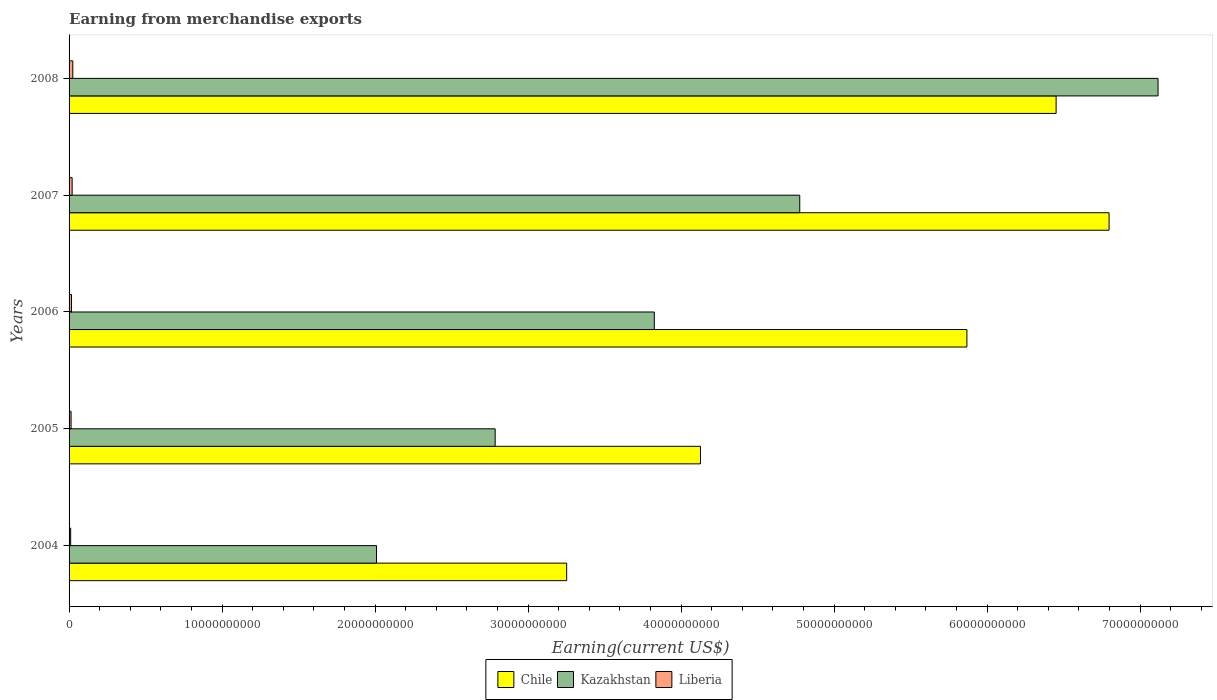How many different coloured bars are there?
Offer a very short reply. 3. How many groups of bars are there?
Your answer should be compact. 5. Are the number of bars per tick equal to the number of legend labels?
Your answer should be compact. Yes. How many bars are there on the 3rd tick from the bottom?
Ensure brevity in your answer.  3. What is the amount earned from merchandise exports in Liberia in 2008?
Provide a succinct answer. 2.42e+08. Across all years, what is the maximum amount earned from merchandise exports in Liberia?
Give a very brief answer. 2.42e+08. Across all years, what is the minimum amount earned from merchandise exports in Liberia?
Your answer should be compact. 1.04e+08. In which year was the amount earned from merchandise exports in Chile maximum?
Give a very brief answer. 2007. What is the total amount earned from merchandise exports in Chile in the graph?
Give a very brief answer. 2.65e+11. What is the difference between the amount earned from merchandise exports in Liberia in 2006 and that in 2008?
Make the answer very short. -8.46e+07. What is the difference between the amount earned from merchandise exports in Kazakhstan in 2006 and the amount earned from merchandise exports in Chile in 2008?
Offer a terse response. -2.63e+1. What is the average amount earned from merchandise exports in Chile per year?
Your answer should be compact. 5.30e+1. In the year 2004, what is the difference between the amount earned from merchandise exports in Liberia and amount earned from merchandise exports in Kazakhstan?
Provide a succinct answer. -2.00e+1. In how many years, is the amount earned from merchandise exports in Chile greater than 44000000000 US$?
Provide a succinct answer. 3. What is the ratio of the amount earned from merchandise exports in Kazakhstan in 2004 to that in 2008?
Ensure brevity in your answer.  0.28. Is the amount earned from merchandise exports in Kazakhstan in 2006 less than that in 2008?
Offer a very short reply. Yes. What is the difference between the highest and the second highest amount earned from merchandise exports in Chile?
Your answer should be very brief. 3.46e+09. What is the difference between the highest and the lowest amount earned from merchandise exports in Liberia?
Offer a very short reply. 1.39e+08. In how many years, is the amount earned from merchandise exports in Chile greater than the average amount earned from merchandise exports in Chile taken over all years?
Offer a terse response. 3. Is the sum of the amount earned from merchandise exports in Chile in 2004 and 2005 greater than the maximum amount earned from merchandise exports in Kazakhstan across all years?
Provide a succinct answer. Yes. What does the 3rd bar from the top in 2004 represents?
Give a very brief answer. Chile. What does the 3rd bar from the bottom in 2008 represents?
Provide a short and direct response. Liberia. Is it the case that in every year, the sum of the amount earned from merchandise exports in Chile and amount earned from merchandise exports in Kazakhstan is greater than the amount earned from merchandise exports in Liberia?
Offer a terse response. Yes. How many years are there in the graph?
Offer a very short reply. 5. Are the values on the major ticks of X-axis written in scientific E-notation?
Your answer should be very brief. No. Does the graph contain grids?
Make the answer very short. No. How many legend labels are there?
Offer a very short reply. 3. How are the legend labels stacked?
Your answer should be very brief. Horizontal. What is the title of the graph?
Your answer should be compact. Earning from merchandise exports. Does "Timor-Leste" appear as one of the legend labels in the graph?
Give a very brief answer. No. What is the label or title of the X-axis?
Provide a short and direct response. Earning(current US$). What is the Earning(current US$) in Chile in 2004?
Provide a short and direct response. 3.25e+1. What is the Earning(current US$) in Kazakhstan in 2004?
Your response must be concise. 2.01e+1. What is the Earning(current US$) of Liberia in 2004?
Ensure brevity in your answer.  1.04e+08. What is the Earning(current US$) in Chile in 2005?
Ensure brevity in your answer.  4.13e+1. What is the Earning(current US$) of Kazakhstan in 2005?
Offer a very short reply. 2.78e+1. What is the Earning(current US$) in Liberia in 2005?
Keep it short and to the point. 1.31e+08. What is the Earning(current US$) in Chile in 2006?
Offer a terse response. 5.87e+1. What is the Earning(current US$) in Kazakhstan in 2006?
Ensure brevity in your answer.  3.82e+1. What is the Earning(current US$) in Liberia in 2006?
Your response must be concise. 1.58e+08. What is the Earning(current US$) of Chile in 2007?
Give a very brief answer. 6.80e+1. What is the Earning(current US$) in Kazakhstan in 2007?
Your response must be concise. 4.78e+1. What is the Earning(current US$) in Liberia in 2007?
Provide a short and direct response. 2.00e+08. What is the Earning(current US$) in Chile in 2008?
Provide a short and direct response. 6.45e+1. What is the Earning(current US$) in Kazakhstan in 2008?
Offer a very short reply. 7.12e+1. What is the Earning(current US$) in Liberia in 2008?
Ensure brevity in your answer.  2.42e+08. Across all years, what is the maximum Earning(current US$) of Chile?
Provide a succinct answer. 6.80e+1. Across all years, what is the maximum Earning(current US$) of Kazakhstan?
Provide a short and direct response. 7.12e+1. Across all years, what is the maximum Earning(current US$) of Liberia?
Your answer should be very brief. 2.42e+08. Across all years, what is the minimum Earning(current US$) of Chile?
Your answer should be very brief. 3.25e+1. Across all years, what is the minimum Earning(current US$) in Kazakhstan?
Provide a short and direct response. 2.01e+1. Across all years, what is the minimum Earning(current US$) of Liberia?
Give a very brief answer. 1.04e+08. What is the total Earning(current US$) of Chile in the graph?
Provide a short and direct response. 2.65e+11. What is the total Earning(current US$) of Kazakhstan in the graph?
Provide a short and direct response. 2.05e+11. What is the total Earning(current US$) of Liberia in the graph?
Make the answer very short. 8.36e+08. What is the difference between the Earning(current US$) of Chile in 2004 and that in 2005?
Your answer should be very brief. -8.75e+09. What is the difference between the Earning(current US$) of Kazakhstan in 2004 and that in 2005?
Provide a short and direct response. -7.76e+09. What is the difference between the Earning(current US$) of Liberia in 2004 and that in 2005?
Your response must be concise. -2.75e+07. What is the difference between the Earning(current US$) in Chile in 2004 and that in 2006?
Your answer should be very brief. -2.62e+1. What is the difference between the Earning(current US$) in Kazakhstan in 2004 and that in 2006?
Offer a terse response. -1.82e+1. What is the difference between the Earning(current US$) in Liberia in 2004 and that in 2006?
Keep it short and to the point. -5.40e+07. What is the difference between the Earning(current US$) in Chile in 2004 and that in 2007?
Your answer should be compact. -3.55e+1. What is the difference between the Earning(current US$) of Kazakhstan in 2004 and that in 2007?
Provide a short and direct response. -2.77e+1. What is the difference between the Earning(current US$) of Liberia in 2004 and that in 2007?
Keep it short and to the point. -9.64e+07. What is the difference between the Earning(current US$) in Chile in 2004 and that in 2008?
Make the answer very short. -3.20e+1. What is the difference between the Earning(current US$) of Kazakhstan in 2004 and that in 2008?
Your answer should be compact. -5.11e+1. What is the difference between the Earning(current US$) of Liberia in 2004 and that in 2008?
Keep it short and to the point. -1.39e+08. What is the difference between the Earning(current US$) in Chile in 2005 and that in 2006?
Provide a short and direct response. -1.74e+1. What is the difference between the Earning(current US$) in Kazakhstan in 2005 and that in 2006?
Offer a terse response. -1.04e+1. What is the difference between the Earning(current US$) of Liberia in 2005 and that in 2006?
Your answer should be very brief. -2.65e+07. What is the difference between the Earning(current US$) of Chile in 2005 and that in 2007?
Provide a succinct answer. -2.67e+1. What is the difference between the Earning(current US$) of Kazakhstan in 2005 and that in 2007?
Your response must be concise. -1.99e+1. What is the difference between the Earning(current US$) of Liberia in 2005 and that in 2007?
Ensure brevity in your answer.  -6.89e+07. What is the difference between the Earning(current US$) of Chile in 2005 and that in 2008?
Offer a very short reply. -2.32e+1. What is the difference between the Earning(current US$) of Kazakhstan in 2005 and that in 2008?
Give a very brief answer. -4.33e+1. What is the difference between the Earning(current US$) in Liberia in 2005 and that in 2008?
Provide a short and direct response. -1.11e+08. What is the difference between the Earning(current US$) in Chile in 2006 and that in 2007?
Give a very brief answer. -9.29e+09. What is the difference between the Earning(current US$) in Kazakhstan in 2006 and that in 2007?
Your response must be concise. -9.50e+09. What is the difference between the Earning(current US$) in Liberia in 2006 and that in 2007?
Keep it short and to the point. -4.24e+07. What is the difference between the Earning(current US$) of Chile in 2006 and that in 2008?
Offer a terse response. -5.83e+09. What is the difference between the Earning(current US$) in Kazakhstan in 2006 and that in 2008?
Give a very brief answer. -3.29e+1. What is the difference between the Earning(current US$) in Liberia in 2006 and that in 2008?
Your answer should be very brief. -8.46e+07. What is the difference between the Earning(current US$) in Chile in 2007 and that in 2008?
Give a very brief answer. 3.46e+09. What is the difference between the Earning(current US$) of Kazakhstan in 2007 and that in 2008?
Your response must be concise. -2.34e+1. What is the difference between the Earning(current US$) of Liberia in 2007 and that in 2008?
Ensure brevity in your answer.  -4.22e+07. What is the difference between the Earning(current US$) of Chile in 2004 and the Earning(current US$) of Kazakhstan in 2005?
Offer a terse response. 4.67e+09. What is the difference between the Earning(current US$) in Chile in 2004 and the Earning(current US$) in Liberia in 2005?
Provide a succinct answer. 3.24e+1. What is the difference between the Earning(current US$) of Kazakhstan in 2004 and the Earning(current US$) of Liberia in 2005?
Give a very brief answer. 2.00e+1. What is the difference between the Earning(current US$) in Chile in 2004 and the Earning(current US$) in Kazakhstan in 2006?
Make the answer very short. -5.73e+09. What is the difference between the Earning(current US$) of Chile in 2004 and the Earning(current US$) of Liberia in 2006?
Keep it short and to the point. 3.24e+1. What is the difference between the Earning(current US$) in Kazakhstan in 2004 and the Earning(current US$) in Liberia in 2006?
Give a very brief answer. 1.99e+1. What is the difference between the Earning(current US$) in Chile in 2004 and the Earning(current US$) in Kazakhstan in 2007?
Ensure brevity in your answer.  -1.52e+1. What is the difference between the Earning(current US$) of Chile in 2004 and the Earning(current US$) of Liberia in 2007?
Your answer should be very brief. 3.23e+1. What is the difference between the Earning(current US$) in Kazakhstan in 2004 and the Earning(current US$) in Liberia in 2007?
Your answer should be very brief. 1.99e+1. What is the difference between the Earning(current US$) of Chile in 2004 and the Earning(current US$) of Kazakhstan in 2008?
Provide a short and direct response. -3.87e+1. What is the difference between the Earning(current US$) of Chile in 2004 and the Earning(current US$) of Liberia in 2008?
Your answer should be compact. 3.23e+1. What is the difference between the Earning(current US$) in Kazakhstan in 2004 and the Earning(current US$) in Liberia in 2008?
Your answer should be very brief. 1.99e+1. What is the difference between the Earning(current US$) in Chile in 2005 and the Earning(current US$) in Kazakhstan in 2006?
Offer a very short reply. 3.02e+09. What is the difference between the Earning(current US$) in Chile in 2005 and the Earning(current US$) in Liberia in 2006?
Make the answer very short. 4.11e+1. What is the difference between the Earning(current US$) of Kazakhstan in 2005 and the Earning(current US$) of Liberia in 2006?
Make the answer very short. 2.77e+1. What is the difference between the Earning(current US$) in Chile in 2005 and the Earning(current US$) in Kazakhstan in 2007?
Your answer should be compact. -6.49e+09. What is the difference between the Earning(current US$) of Chile in 2005 and the Earning(current US$) of Liberia in 2007?
Provide a succinct answer. 4.11e+1. What is the difference between the Earning(current US$) of Kazakhstan in 2005 and the Earning(current US$) of Liberia in 2007?
Offer a terse response. 2.76e+1. What is the difference between the Earning(current US$) in Chile in 2005 and the Earning(current US$) in Kazakhstan in 2008?
Your response must be concise. -2.99e+1. What is the difference between the Earning(current US$) in Chile in 2005 and the Earning(current US$) in Liberia in 2008?
Give a very brief answer. 4.10e+1. What is the difference between the Earning(current US$) of Kazakhstan in 2005 and the Earning(current US$) of Liberia in 2008?
Your answer should be compact. 2.76e+1. What is the difference between the Earning(current US$) in Chile in 2006 and the Earning(current US$) in Kazakhstan in 2007?
Offer a very short reply. 1.09e+1. What is the difference between the Earning(current US$) of Chile in 2006 and the Earning(current US$) of Liberia in 2007?
Offer a very short reply. 5.85e+1. What is the difference between the Earning(current US$) in Kazakhstan in 2006 and the Earning(current US$) in Liberia in 2007?
Your answer should be very brief. 3.80e+1. What is the difference between the Earning(current US$) in Chile in 2006 and the Earning(current US$) in Kazakhstan in 2008?
Your answer should be very brief. -1.25e+1. What is the difference between the Earning(current US$) of Chile in 2006 and the Earning(current US$) of Liberia in 2008?
Your response must be concise. 5.84e+1. What is the difference between the Earning(current US$) in Kazakhstan in 2006 and the Earning(current US$) in Liberia in 2008?
Give a very brief answer. 3.80e+1. What is the difference between the Earning(current US$) of Chile in 2007 and the Earning(current US$) of Kazakhstan in 2008?
Offer a terse response. -3.20e+09. What is the difference between the Earning(current US$) in Chile in 2007 and the Earning(current US$) in Liberia in 2008?
Provide a succinct answer. 6.77e+1. What is the difference between the Earning(current US$) of Kazakhstan in 2007 and the Earning(current US$) of Liberia in 2008?
Your answer should be very brief. 4.75e+1. What is the average Earning(current US$) in Chile per year?
Your response must be concise. 5.30e+1. What is the average Earning(current US$) of Kazakhstan per year?
Your response must be concise. 4.10e+1. What is the average Earning(current US$) of Liberia per year?
Provide a succinct answer. 1.67e+08. In the year 2004, what is the difference between the Earning(current US$) of Chile and Earning(current US$) of Kazakhstan?
Make the answer very short. 1.24e+1. In the year 2004, what is the difference between the Earning(current US$) in Chile and Earning(current US$) in Liberia?
Your answer should be very brief. 3.24e+1. In the year 2004, what is the difference between the Earning(current US$) in Kazakhstan and Earning(current US$) in Liberia?
Make the answer very short. 2.00e+1. In the year 2005, what is the difference between the Earning(current US$) of Chile and Earning(current US$) of Kazakhstan?
Offer a very short reply. 1.34e+1. In the year 2005, what is the difference between the Earning(current US$) in Chile and Earning(current US$) in Liberia?
Offer a very short reply. 4.11e+1. In the year 2005, what is the difference between the Earning(current US$) in Kazakhstan and Earning(current US$) in Liberia?
Make the answer very short. 2.77e+1. In the year 2006, what is the difference between the Earning(current US$) of Chile and Earning(current US$) of Kazakhstan?
Provide a succinct answer. 2.04e+1. In the year 2006, what is the difference between the Earning(current US$) in Chile and Earning(current US$) in Liberia?
Your response must be concise. 5.85e+1. In the year 2006, what is the difference between the Earning(current US$) of Kazakhstan and Earning(current US$) of Liberia?
Offer a terse response. 3.81e+1. In the year 2007, what is the difference between the Earning(current US$) of Chile and Earning(current US$) of Kazakhstan?
Your response must be concise. 2.02e+1. In the year 2007, what is the difference between the Earning(current US$) in Chile and Earning(current US$) in Liberia?
Your answer should be very brief. 6.78e+1. In the year 2007, what is the difference between the Earning(current US$) of Kazakhstan and Earning(current US$) of Liberia?
Keep it short and to the point. 4.76e+1. In the year 2008, what is the difference between the Earning(current US$) in Chile and Earning(current US$) in Kazakhstan?
Offer a terse response. -6.66e+09. In the year 2008, what is the difference between the Earning(current US$) of Chile and Earning(current US$) of Liberia?
Keep it short and to the point. 6.43e+1. In the year 2008, what is the difference between the Earning(current US$) of Kazakhstan and Earning(current US$) of Liberia?
Provide a short and direct response. 7.09e+1. What is the ratio of the Earning(current US$) in Chile in 2004 to that in 2005?
Offer a terse response. 0.79. What is the ratio of the Earning(current US$) of Kazakhstan in 2004 to that in 2005?
Give a very brief answer. 0.72. What is the ratio of the Earning(current US$) of Liberia in 2004 to that in 2005?
Offer a terse response. 0.79. What is the ratio of the Earning(current US$) of Chile in 2004 to that in 2006?
Provide a short and direct response. 0.55. What is the ratio of the Earning(current US$) of Kazakhstan in 2004 to that in 2006?
Ensure brevity in your answer.  0.53. What is the ratio of the Earning(current US$) in Liberia in 2004 to that in 2006?
Make the answer very short. 0.66. What is the ratio of the Earning(current US$) in Chile in 2004 to that in 2007?
Your answer should be very brief. 0.48. What is the ratio of the Earning(current US$) in Kazakhstan in 2004 to that in 2007?
Provide a short and direct response. 0.42. What is the ratio of the Earning(current US$) of Liberia in 2004 to that in 2007?
Your answer should be compact. 0.52. What is the ratio of the Earning(current US$) in Chile in 2004 to that in 2008?
Offer a very short reply. 0.5. What is the ratio of the Earning(current US$) of Kazakhstan in 2004 to that in 2008?
Give a very brief answer. 0.28. What is the ratio of the Earning(current US$) in Liberia in 2004 to that in 2008?
Your answer should be very brief. 0.43. What is the ratio of the Earning(current US$) of Chile in 2005 to that in 2006?
Give a very brief answer. 0.7. What is the ratio of the Earning(current US$) of Kazakhstan in 2005 to that in 2006?
Offer a terse response. 0.73. What is the ratio of the Earning(current US$) of Liberia in 2005 to that in 2006?
Your answer should be very brief. 0.83. What is the ratio of the Earning(current US$) in Chile in 2005 to that in 2007?
Offer a terse response. 0.61. What is the ratio of the Earning(current US$) in Kazakhstan in 2005 to that in 2007?
Provide a succinct answer. 0.58. What is the ratio of the Earning(current US$) of Liberia in 2005 to that in 2007?
Your response must be concise. 0.66. What is the ratio of the Earning(current US$) in Chile in 2005 to that in 2008?
Your answer should be compact. 0.64. What is the ratio of the Earning(current US$) of Kazakhstan in 2005 to that in 2008?
Give a very brief answer. 0.39. What is the ratio of the Earning(current US$) in Liberia in 2005 to that in 2008?
Your response must be concise. 0.54. What is the ratio of the Earning(current US$) in Chile in 2006 to that in 2007?
Offer a terse response. 0.86. What is the ratio of the Earning(current US$) in Kazakhstan in 2006 to that in 2007?
Your response must be concise. 0.8. What is the ratio of the Earning(current US$) of Liberia in 2006 to that in 2007?
Ensure brevity in your answer.  0.79. What is the ratio of the Earning(current US$) of Chile in 2006 to that in 2008?
Your response must be concise. 0.91. What is the ratio of the Earning(current US$) in Kazakhstan in 2006 to that in 2008?
Ensure brevity in your answer.  0.54. What is the ratio of the Earning(current US$) in Liberia in 2006 to that in 2008?
Make the answer very short. 0.65. What is the ratio of the Earning(current US$) in Chile in 2007 to that in 2008?
Give a very brief answer. 1.05. What is the ratio of the Earning(current US$) of Kazakhstan in 2007 to that in 2008?
Provide a short and direct response. 0.67. What is the ratio of the Earning(current US$) of Liberia in 2007 to that in 2008?
Provide a succinct answer. 0.83. What is the difference between the highest and the second highest Earning(current US$) of Chile?
Provide a succinct answer. 3.46e+09. What is the difference between the highest and the second highest Earning(current US$) of Kazakhstan?
Give a very brief answer. 2.34e+1. What is the difference between the highest and the second highest Earning(current US$) in Liberia?
Offer a terse response. 4.22e+07. What is the difference between the highest and the lowest Earning(current US$) in Chile?
Offer a terse response. 3.55e+1. What is the difference between the highest and the lowest Earning(current US$) in Kazakhstan?
Your answer should be very brief. 5.11e+1. What is the difference between the highest and the lowest Earning(current US$) of Liberia?
Keep it short and to the point. 1.39e+08. 